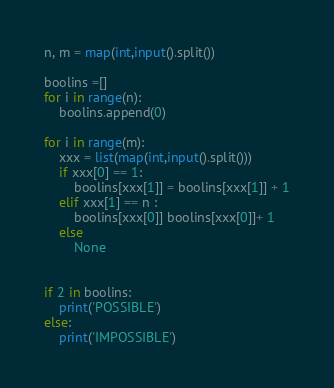<code> <loc_0><loc_0><loc_500><loc_500><_Python_>n, m = map(int,input().split())

boolins =[]
for i in range(n):
    boolins.append(0)
    
for i in range(m):
    xxx = list(map(int,input().split()))
    if xxx[0] == 1:
        boolins[xxx[1]] = boolins[xxx[1]] + 1
    elif xxx[1] == n :
        boolins[xxx[0]] boolins[xxx[0]]+ 1
    else
        None


if 2 in boolins:
    print('POSSIBLE')
else:
    print('IMPOSSIBLE')</code> 